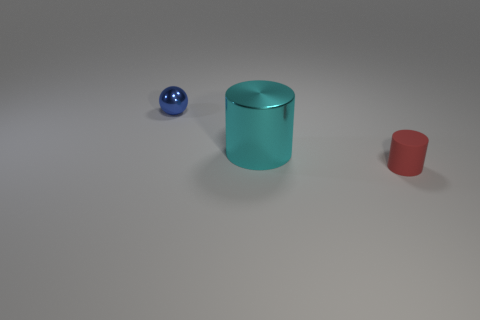Add 1 metallic objects. How many objects exist? 4 Subtract all cylinders. How many objects are left? 1 Add 1 large objects. How many large objects are left? 2 Add 1 rubber cylinders. How many rubber cylinders exist? 2 Subtract 0 red spheres. How many objects are left? 3 Subtract all small red matte cylinders. Subtract all big cylinders. How many objects are left? 1 